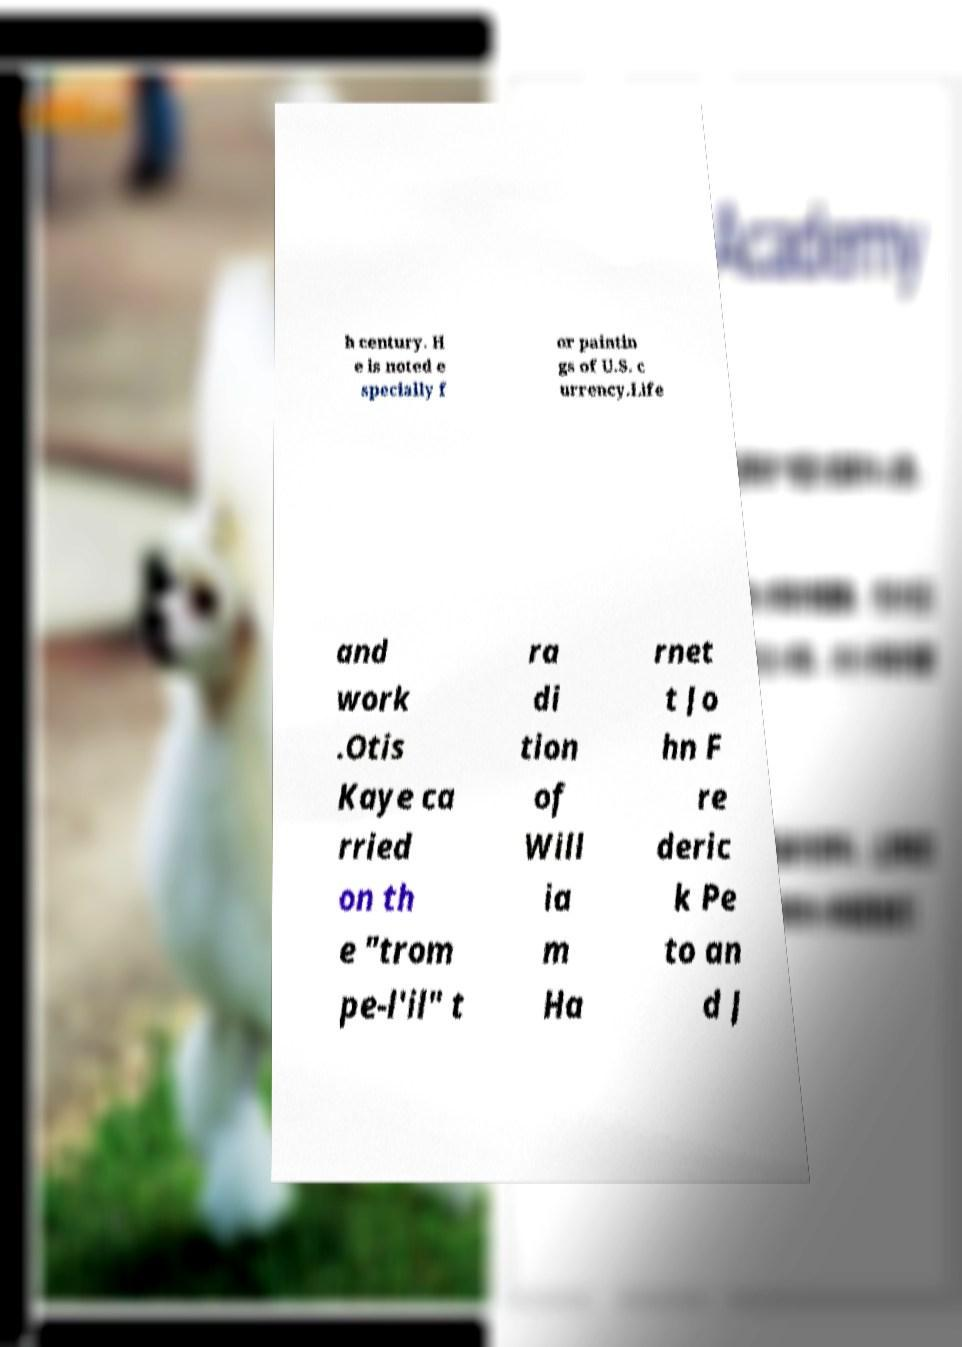Could you assist in decoding the text presented in this image and type it out clearly? h century. H e is noted e specially f or paintin gs of U.S. c urrency.Life and work .Otis Kaye ca rried on th e "trom pe-l'il" t ra di tion of Will ia m Ha rnet t Jo hn F re deric k Pe to an d J 